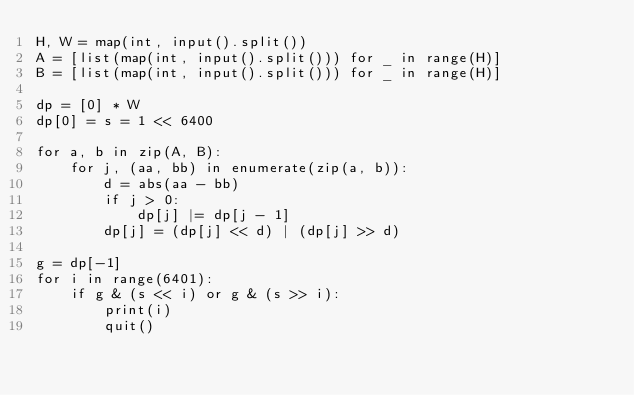<code> <loc_0><loc_0><loc_500><loc_500><_Python_>H, W = map(int, input().split())
A = [list(map(int, input().split())) for _ in range(H)]
B = [list(map(int, input().split())) for _ in range(H)]

dp = [0] * W
dp[0] = s = 1 << 6400

for a, b in zip(A, B):
    for j, (aa, bb) in enumerate(zip(a, b)):
        d = abs(aa - bb)
        if j > 0:
            dp[j] |= dp[j - 1]
        dp[j] = (dp[j] << d) | (dp[j] >> d)

g = dp[-1]
for i in range(6401):
    if g & (s << i) or g & (s >> i):
        print(i)
        quit()</code> 